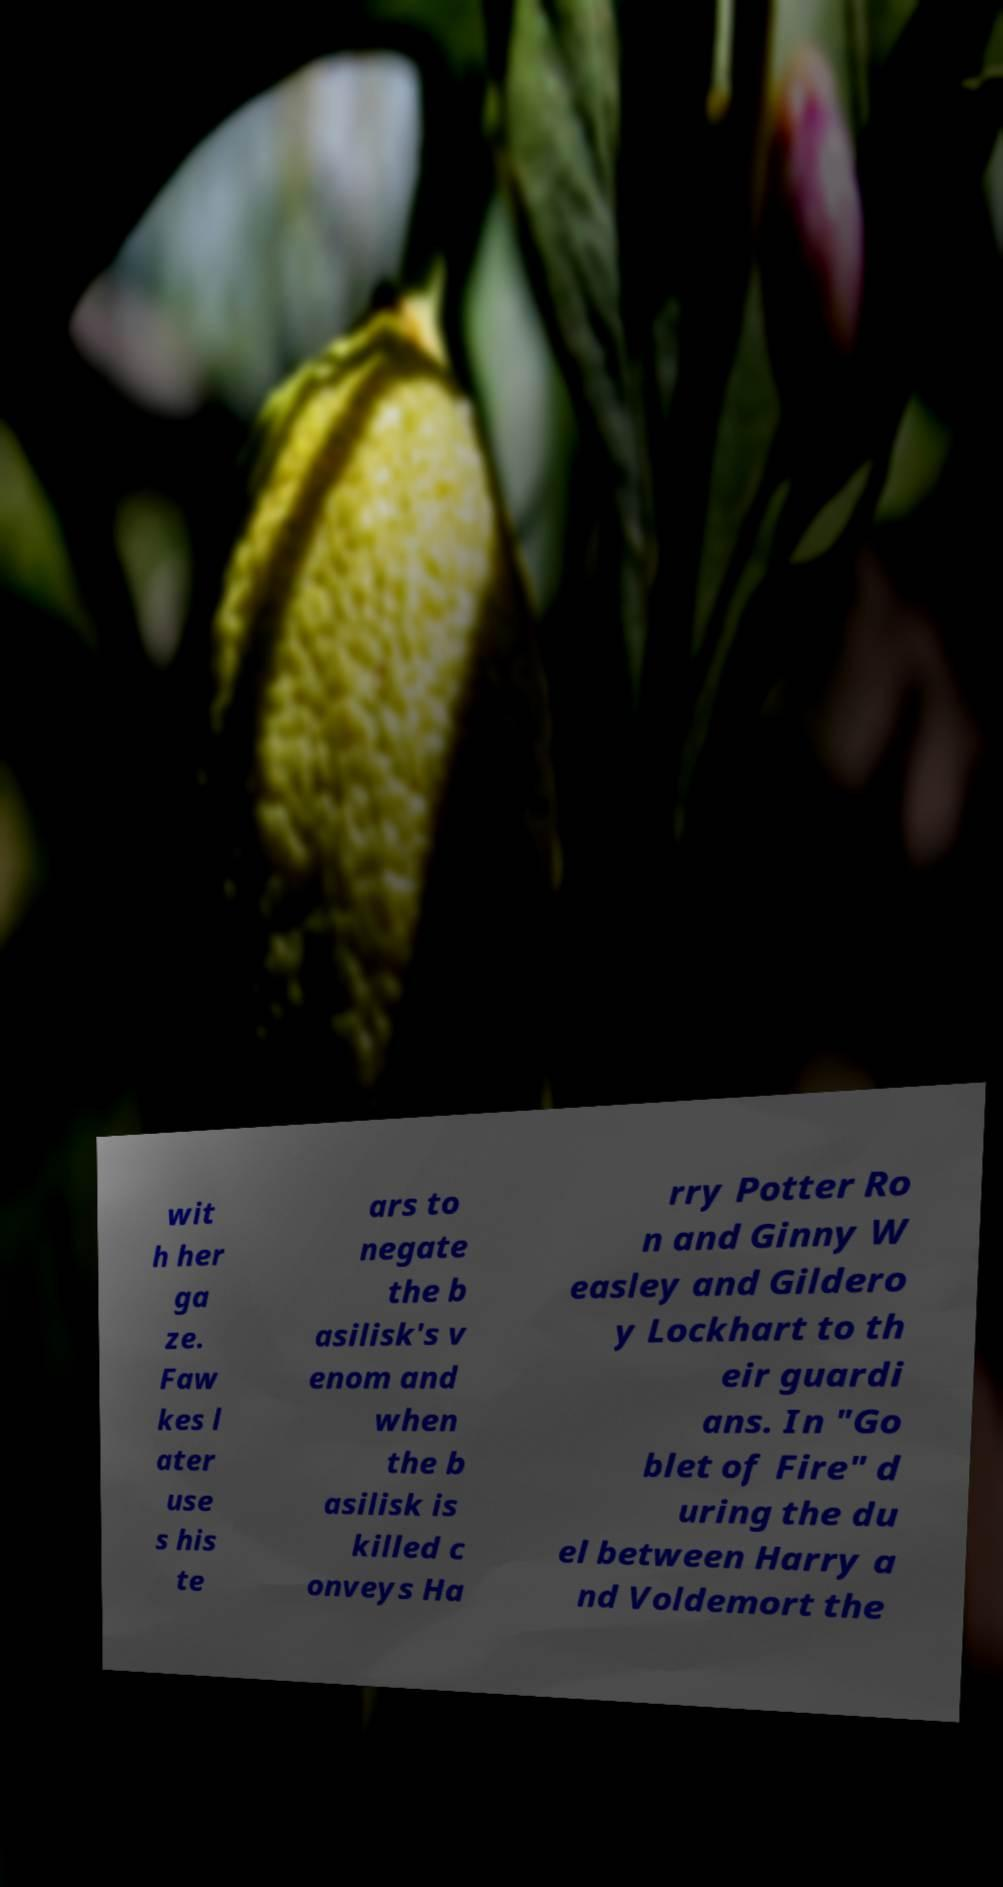Please read and relay the text visible in this image. What does it say? wit h her ga ze. Faw kes l ater use s his te ars to negate the b asilisk's v enom and when the b asilisk is killed c onveys Ha rry Potter Ro n and Ginny W easley and Gildero y Lockhart to th eir guardi ans. In "Go blet of Fire" d uring the du el between Harry a nd Voldemort the 